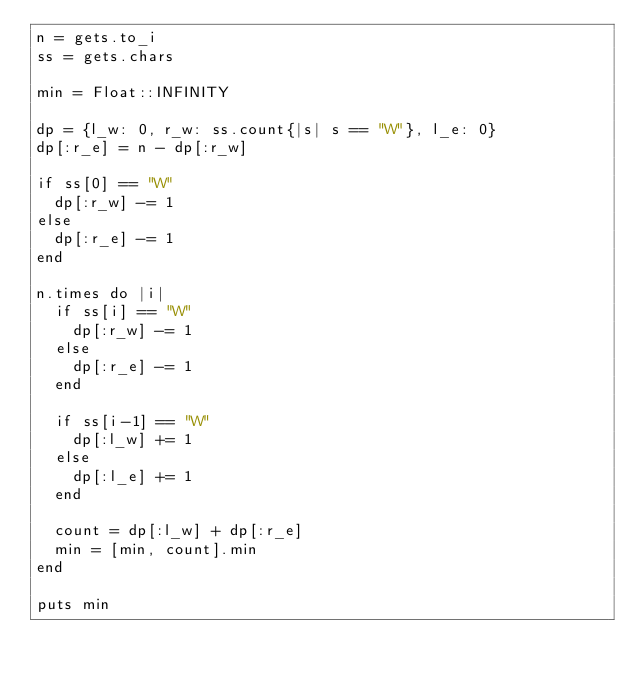Convert code to text. <code><loc_0><loc_0><loc_500><loc_500><_Ruby_>n = gets.to_i
ss = gets.chars

min = Float::INFINITY

dp = {l_w: 0, r_w: ss.count{|s| s == "W"}, l_e: 0}
dp[:r_e] = n - dp[:r_w]

if ss[0] == "W"
  dp[:r_w] -= 1
else
  dp[:r_e] -= 1
end

n.times do |i|
  if ss[i] == "W"
    dp[:r_w] -= 1
  else
    dp[:r_e] -= 1
  end

  if ss[i-1] == "W"
    dp[:l_w] += 1
  else
    dp[:l_e] += 1
  end

  count = dp[:l_w] + dp[:r_e]
  min = [min, count].min
end

puts min</code> 